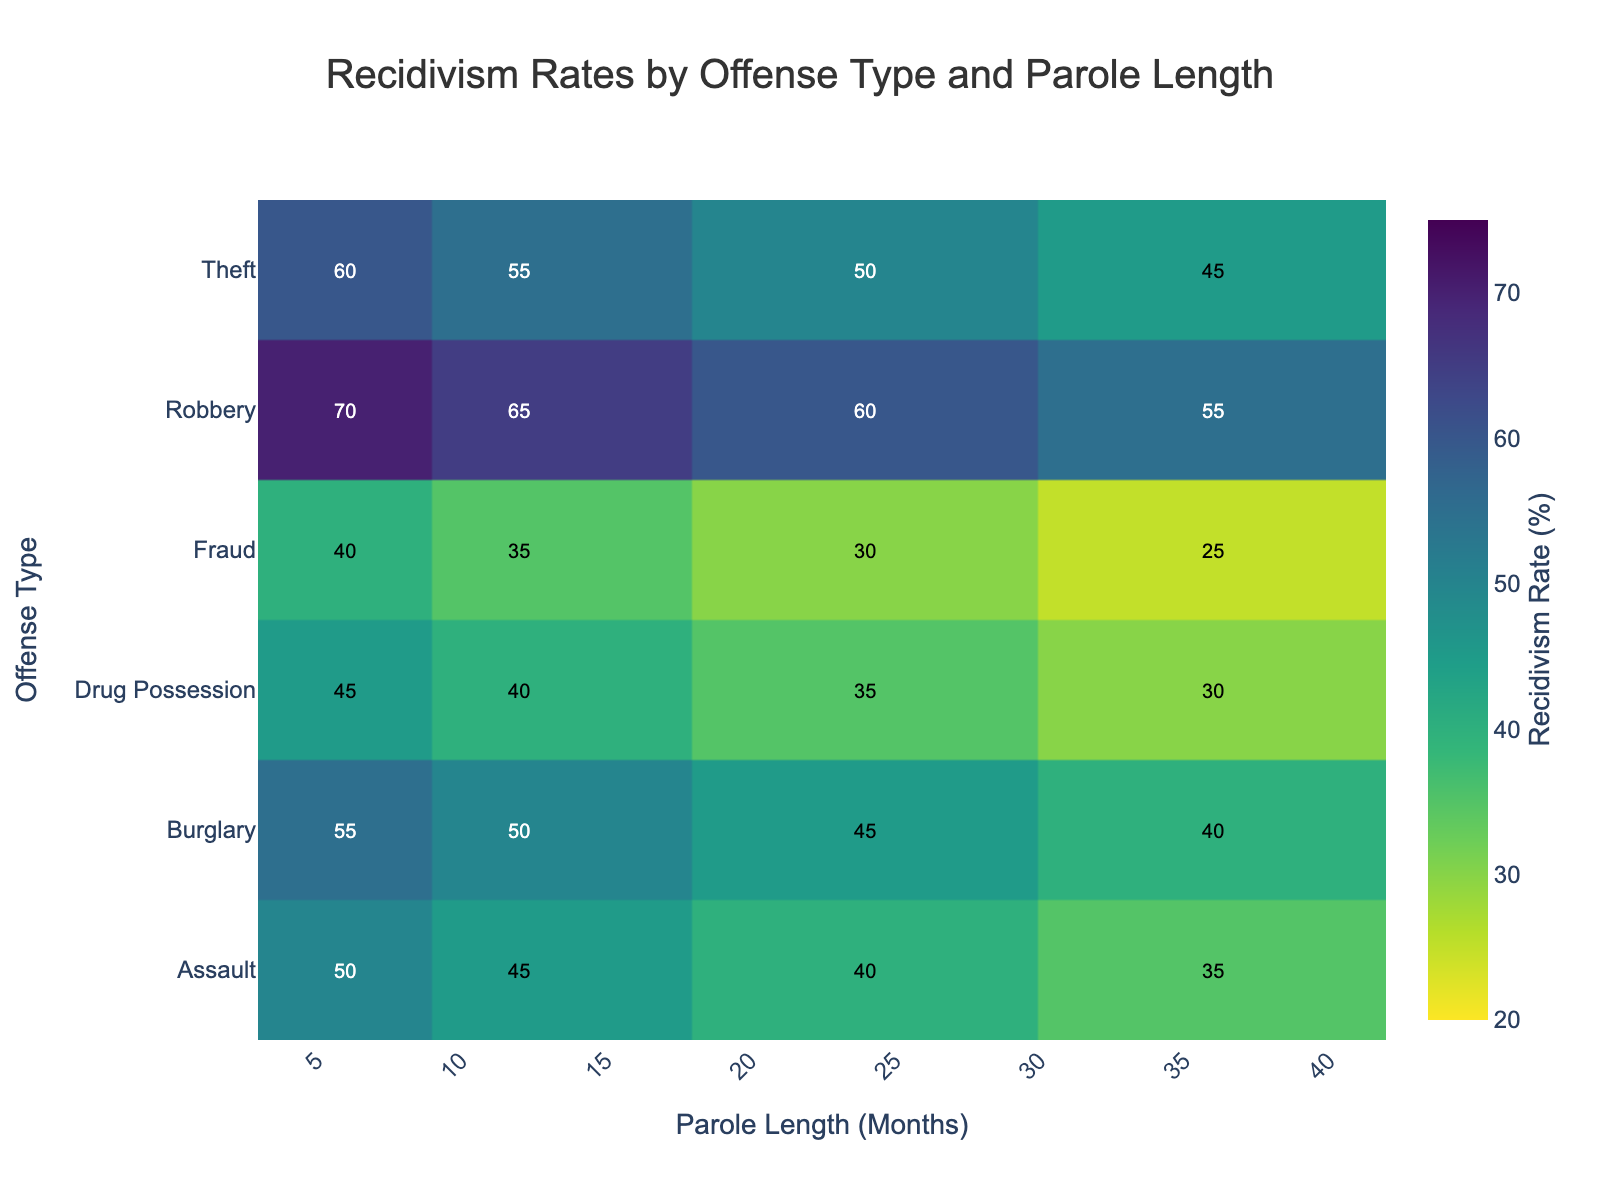What is the title of the heatmap? The title is located at the top of the figure and often summarizes the main subject of the visualization.
Answer: Recidivism Rates by Offense Type and Parole Length Which offense type has the highest recidivism rate at 6 months of parole? Locate the column for 6 months on the x-axis and identify the highest value in that column. The color intensity also helps to spot the highest value.
Answer: Robbery What is the recidivism rate for Fraud at 36 months of parole? Find the row labeled "Fraud" and the column for 36 months. The recidivism rate is the intersection of this row and column.
Answer: 25% How does the recidivism rate for Drug Possession change from 6 months to 36 months of parole? Track the values across the Drug Possession row from 6 months to 36 months and observe the trend, noting any increases or decreases.
Answer: Decreases from 45% to 30% Which offense type shows the steepest decline in recidivism rate from 6 months to 36 months of parole? Compare the rates from 6 months to 36 months for each offense type, then calculate the differences and identify the largest one.
Answer: Fraud What is the average recidivism rate for Assault across all parole lengths? Add the recidivism rates for Assault: (50 + 45 + 40 + 35), then divide by the number of lengths (4). (50+45+40+35)/4 = 170/4
Answer: 42.5% Is the recidivism rate higher for Theft or Burglary at 24 months of parole? Locate the 24-month column, then compare the values for Theft and Burglary.
Answer: Theft (50% vs. 45%) In general, do longer parole lengths correspond to lower recidivism rates? Evaluate the trend for recidivism rates across different parole lengths for each offense type, noting if they generally decline.
Answer: Yes Which offense type has the most consistent recidivism rates across different parole lengths? Check the rates for each offense type across different parole lengths and identify the one with the smallest variation.
Answer: Assault 